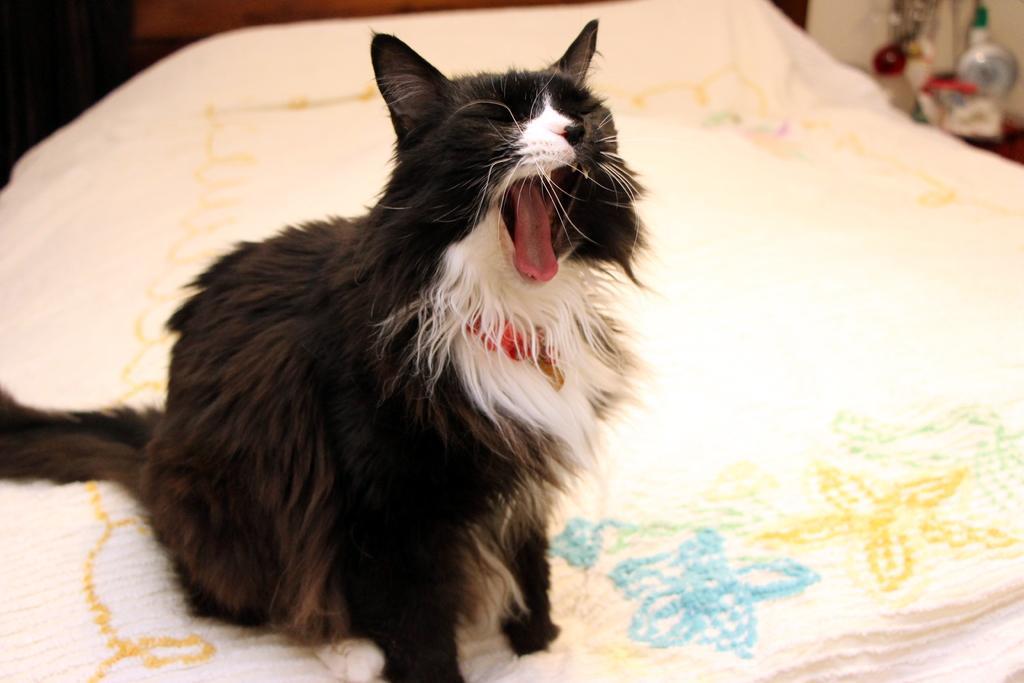In one or two sentences, can you explain what this image depicts? In the picture we can see the cat sitting on the bed and the cat is black in color with some part white to it and opening its mouth and beside the bed we can see some things are placed on the table. 